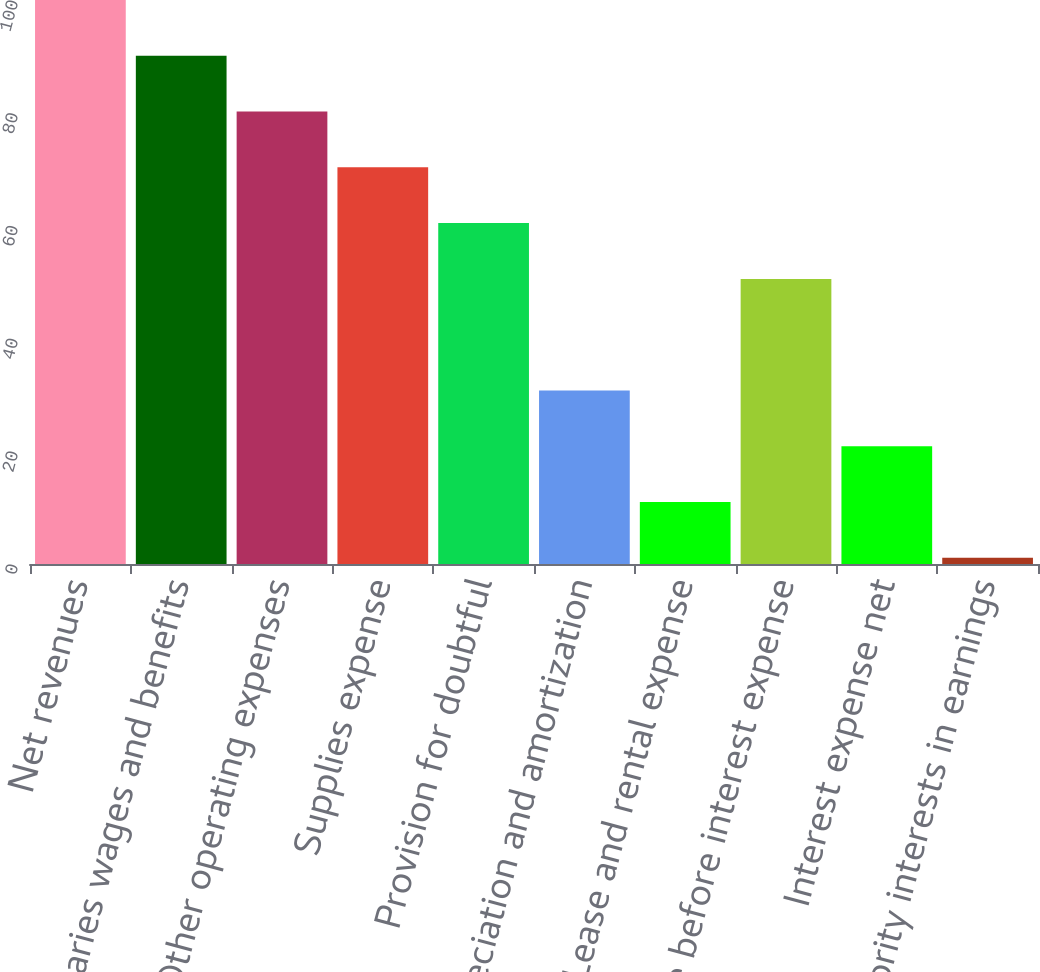Convert chart. <chart><loc_0><loc_0><loc_500><loc_500><bar_chart><fcel>Net revenues<fcel>Salaries wages and benefits<fcel>Other operating expenses<fcel>Supplies expense<fcel>Provision for doubtful<fcel>Depreciation and amortization<fcel>Lease and rental expense<fcel>Income before interest expense<fcel>Interest expense net<fcel>Minority interests in earnings<nl><fcel>100<fcel>90.11<fcel>80.22<fcel>70.33<fcel>60.44<fcel>30.77<fcel>10.99<fcel>50.55<fcel>20.88<fcel>1.1<nl></chart> 